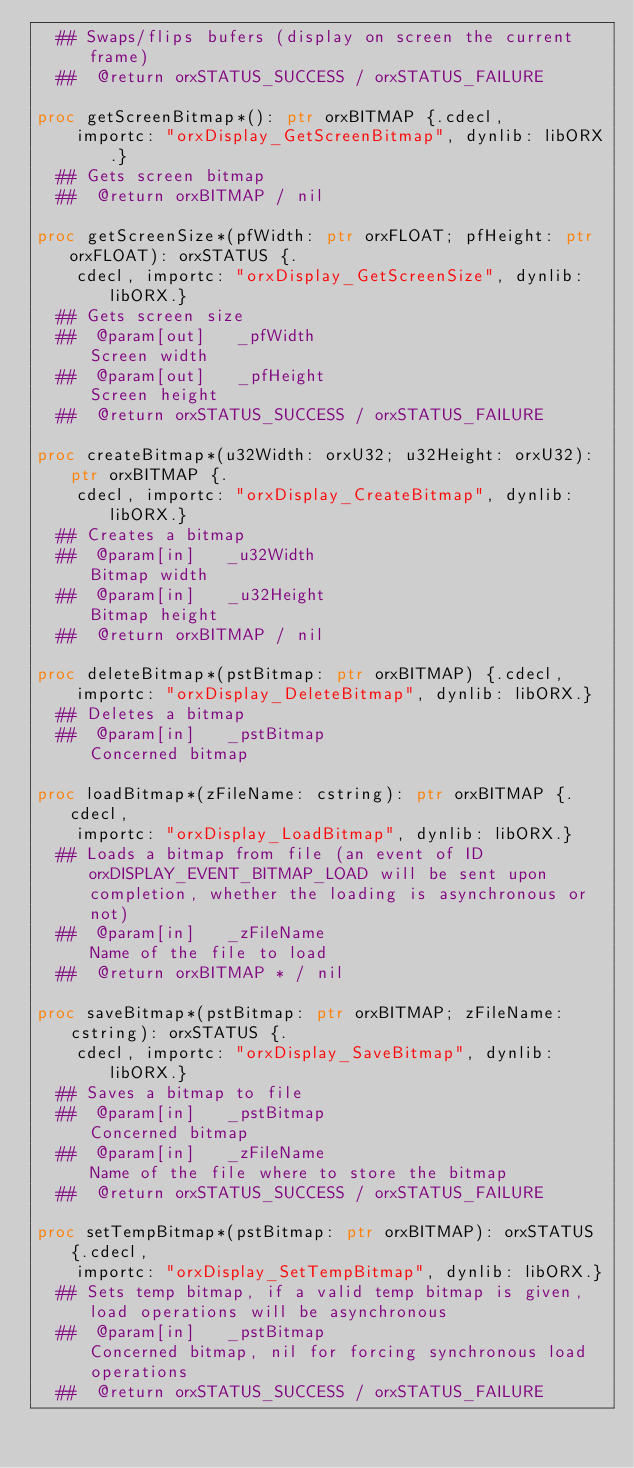Convert code to text. <code><loc_0><loc_0><loc_500><loc_500><_Nim_>  ## Swaps/flips bufers (display on screen the current frame)
  ##  @return orxSTATUS_SUCCESS / orxSTATUS_FAILURE

proc getScreenBitmap*(): ptr orxBITMAP {.cdecl,
    importc: "orxDisplay_GetScreenBitmap", dynlib: libORX.}
  ## Gets screen bitmap
  ##  @return orxBITMAP / nil

proc getScreenSize*(pfWidth: ptr orxFLOAT; pfHeight: ptr orxFLOAT): orxSTATUS {.
    cdecl, importc: "orxDisplay_GetScreenSize", dynlib: libORX.}
  ## Gets screen size
  ##  @param[out]   _pfWidth                             Screen width
  ##  @param[out]   _pfHeight                            Screen height
  ##  @return orxSTATUS_SUCCESS / orxSTATUS_FAILURE

proc createBitmap*(u32Width: orxU32; u32Height: orxU32): ptr orxBITMAP {.
    cdecl, importc: "orxDisplay_CreateBitmap", dynlib: libORX.}
  ## Creates a bitmap
  ##  @param[in]   _u32Width                             Bitmap width
  ##  @param[in]   _u32Height                            Bitmap height
  ##  @return orxBITMAP / nil

proc deleteBitmap*(pstBitmap: ptr orxBITMAP) {.cdecl,
    importc: "orxDisplay_DeleteBitmap", dynlib: libORX.}
  ## Deletes a bitmap
  ##  @param[in]   _pstBitmap                            Concerned bitmap

proc loadBitmap*(zFileName: cstring): ptr orxBITMAP {.cdecl,
    importc: "orxDisplay_LoadBitmap", dynlib: libORX.}
  ## Loads a bitmap from file (an event of ID orxDISPLAY_EVENT_BITMAP_LOAD will be sent upon completion, whether the loading is asynchronous or not)
  ##  @param[in]   _zFileName                            Name of the file to load
  ##  @return orxBITMAP * / nil

proc saveBitmap*(pstBitmap: ptr orxBITMAP; zFileName: cstring): orxSTATUS {.
    cdecl, importc: "orxDisplay_SaveBitmap", dynlib: libORX.}
  ## Saves a bitmap to file
  ##  @param[in]   _pstBitmap                            Concerned bitmap
  ##  @param[in]   _zFileName                            Name of the file where to store the bitmap
  ##  @return orxSTATUS_SUCCESS / orxSTATUS_FAILURE

proc setTempBitmap*(pstBitmap: ptr orxBITMAP): orxSTATUS {.cdecl,
    importc: "orxDisplay_SetTempBitmap", dynlib: libORX.}
  ## Sets temp bitmap, if a valid temp bitmap is given, load operations will be asynchronous
  ##  @param[in]   _pstBitmap                            Concerned bitmap, nil for forcing synchronous load operations
  ##  @return orxSTATUS_SUCCESS / orxSTATUS_FAILURE
</code> 